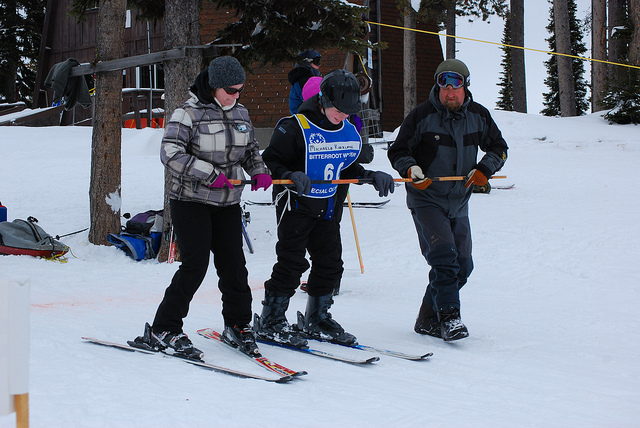Identify the text contained in this image. 6 